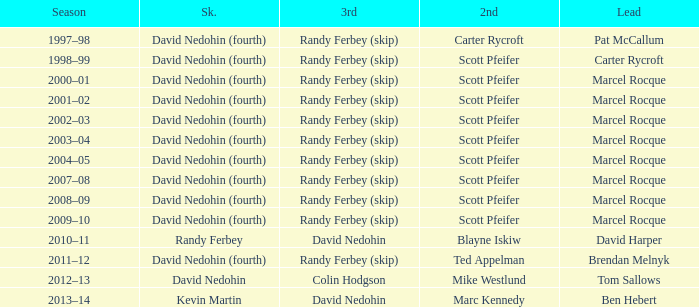Which Lead has a Third of randy ferbey (skip), a Second of scott pfeifer, and a Season of 2009–10? Marcel Rocque. 